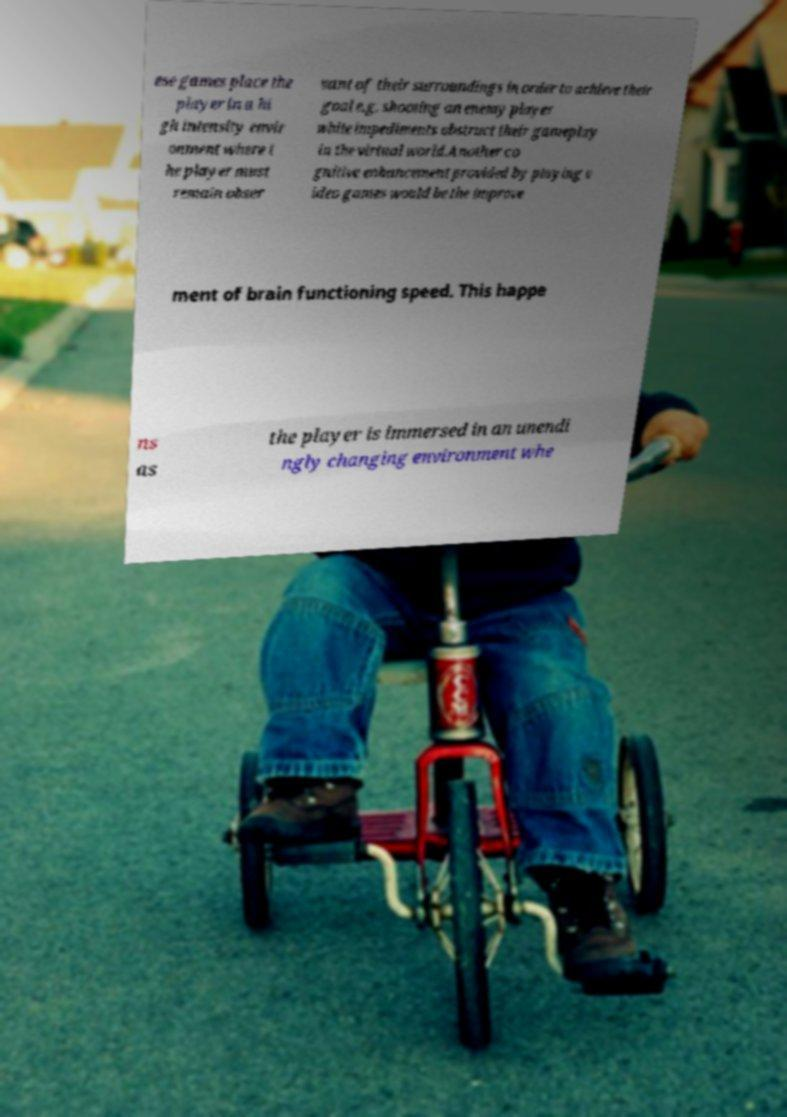For documentation purposes, I need the text within this image transcribed. Could you provide that? ese games place the player in a hi gh intensity envir onment where t he player must remain obser vant of their surroundings in order to achieve their goal e.g. shooting an enemy player while impediments obstruct their gameplay in the virtual world.Another co gnitive enhancement provided by playing v ideo games would be the improve ment of brain functioning speed. This happe ns as the player is immersed in an unendi ngly changing environment whe 